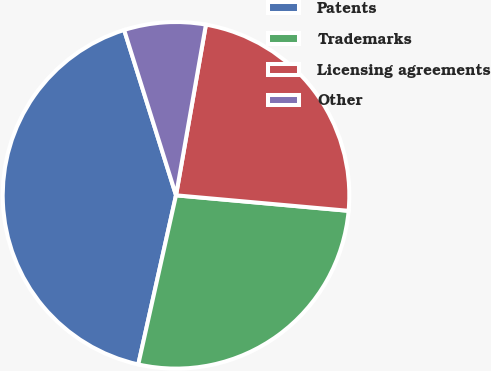Convert chart to OTSL. <chart><loc_0><loc_0><loc_500><loc_500><pie_chart><fcel>Patents<fcel>Trademarks<fcel>Licensing agreements<fcel>Other<nl><fcel>41.67%<fcel>27.07%<fcel>23.67%<fcel>7.6%<nl></chart> 